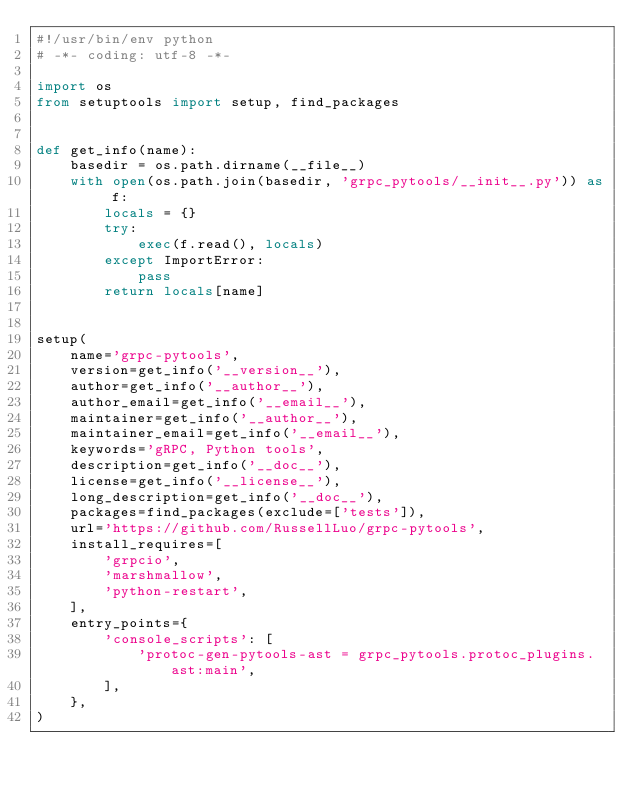<code> <loc_0><loc_0><loc_500><loc_500><_Python_>#!/usr/bin/env python
# -*- coding: utf-8 -*-

import os
from setuptools import setup, find_packages


def get_info(name):
    basedir = os.path.dirname(__file__)
    with open(os.path.join(basedir, 'grpc_pytools/__init__.py')) as f:
        locals = {}
        try:
            exec(f.read(), locals)
        except ImportError:
            pass
        return locals[name]


setup(
    name='grpc-pytools',
    version=get_info('__version__'),
    author=get_info('__author__'),
    author_email=get_info('__email__'),
    maintainer=get_info('__author__'),
    maintainer_email=get_info('__email__'),
    keywords='gRPC, Python tools',
    description=get_info('__doc__'),
    license=get_info('__license__'),
    long_description=get_info('__doc__'),
    packages=find_packages(exclude=['tests']),
    url='https://github.com/RussellLuo/grpc-pytools',
    install_requires=[
        'grpcio',
        'marshmallow',
        'python-restart',
    ],
    entry_points={
        'console_scripts': [
            'protoc-gen-pytools-ast = grpc_pytools.protoc_plugins.ast:main',
        ],
    },
)
</code> 